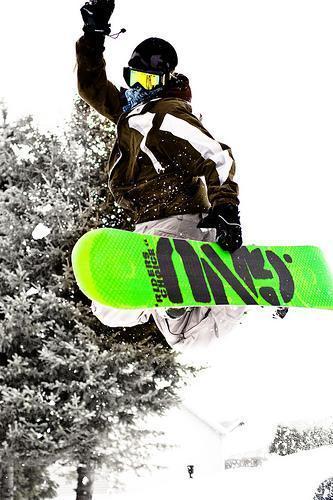How many people are pictured?
Give a very brief answer. 1. 